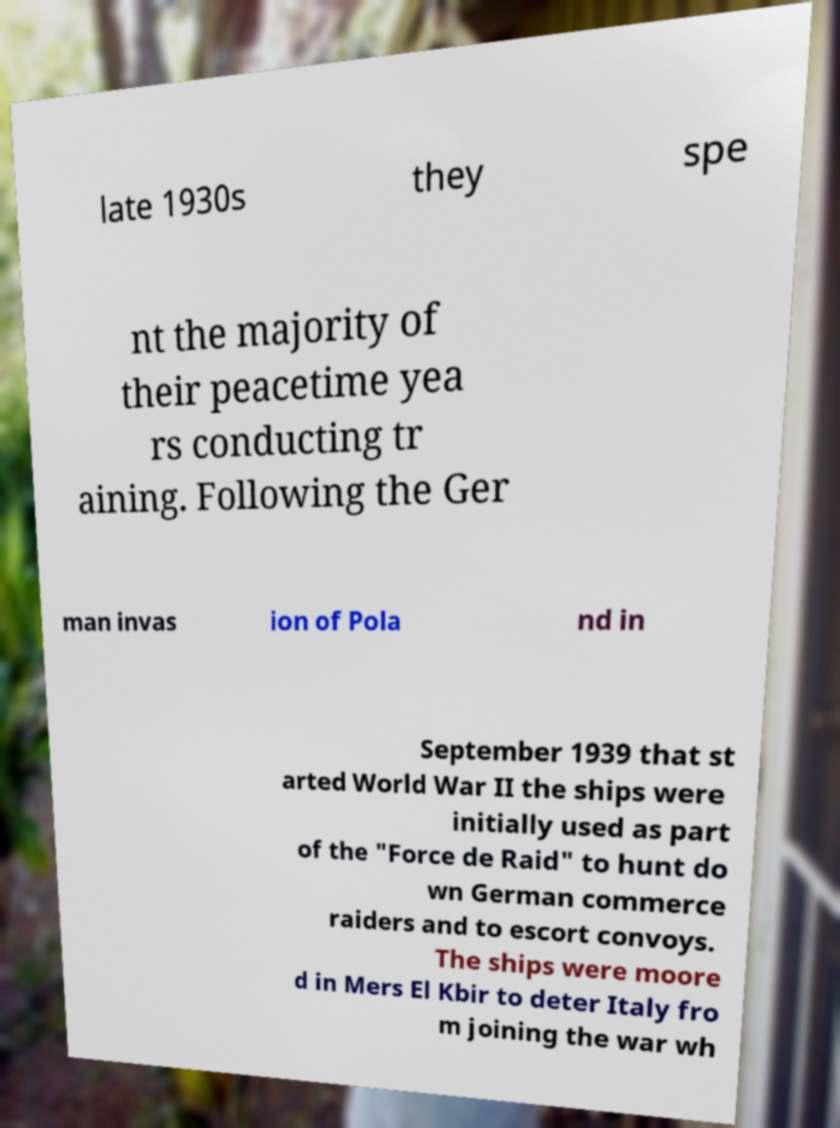For documentation purposes, I need the text within this image transcribed. Could you provide that? late 1930s they spe nt the majority of their peacetime yea rs conducting tr aining. Following the Ger man invas ion of Pola nd in September 1939 that st arted World War II the ships were initially used as part of the "Force de Raid" to hunt do wn German commerce raiders and to escort convoys. The ships were moore d in Mers El Kbir to deter Italy fro m joining the war wh 